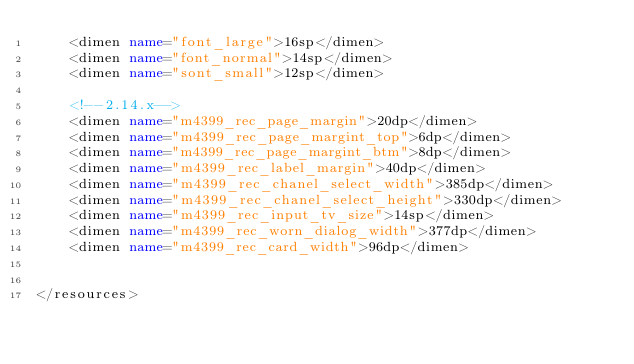Convert code to text. <code><loc_0><loc_0><loc_500><loc_500><_XML_>    <dimen name="font_large">16sp</dimen>
    <dimen name="font_normal">14sp</dimen>
    <dimen name="sont_small">12sp</dimen>

    <!--2.14.x-->
    <dimen name="m4399_rec_page_margin">20dp</dimen>
    <dimen name="m4399_rec_page_margint_top">6dp</dimen>
    <dimen name="m4399_rec_page_margint_btm">8dp</dimen>
    <dimen name="m4399_rec_label_margin">40dp</dimen>
    <dimen name="m4399_rec_chanel_select_width">385dp</dimen>
    <dimen name="m4399_rec_chanel_select_height">330dp</dimen>
    <dimen name="m4399_rec_input_tv_size">14sp</dimen>
    <dimen name="m4399_rec_worn_dialog_width">377dp</dimen>
    <dimen name="m4399_rec_card_width">96dp</dimen>


</resources></code> 